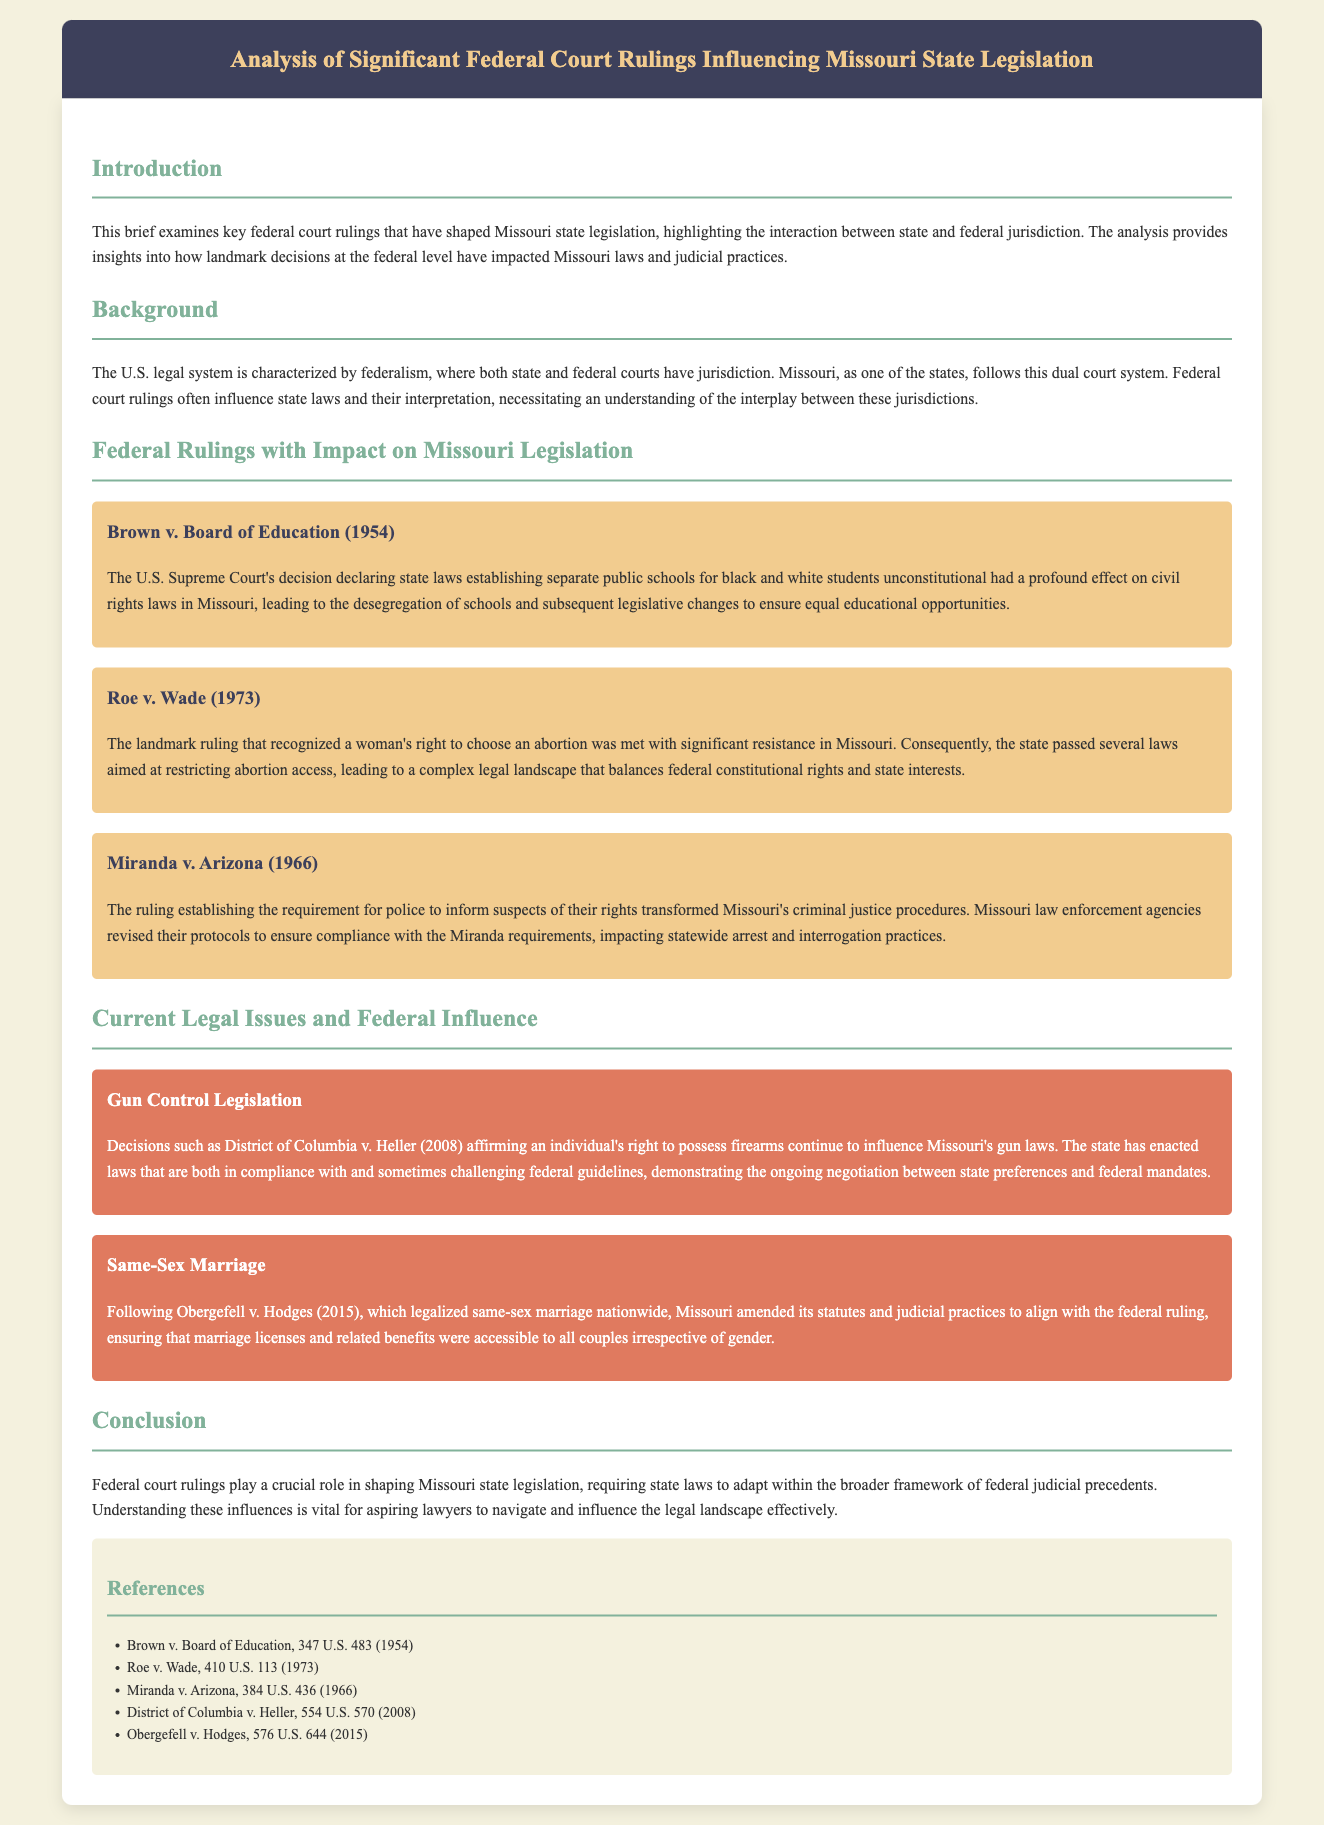What is the title of the brief? The title is prominently displayed in the header of the document, summarizing its focus on federal court rulings and Missouri legislation.
Answer: Analysis of Significant Federal Court Rulings Influencing Missouri State Legislation What year was Brown v. Board of Education decided? This is a landmark case typically recognized in educational contexts, and its citation in the document includes the year of the ruling.
Answer: 1954 Which ruling established the requirement for police to inform suspects of their rights? The document clearly states this ruling as it outlines the changes in Missouri's criminal justice procedures as a result.
Answer: Miranda v. Arizona What major issue does the current legal issue section address following Obergefell v. Hodges? The context of changing statutes and judicial practices in Missouri is outlined in relation to this federal ruling.
Answer: Same-Sex Marriage How many key federal court rulings are specifically mentioned in the brief? The document lists several significant cases that have influenced state legislation, allowing us to count them.
Answer: Five What is the main focus of the introduction section? The introduction outlines the purpose of the brief, which is to analyze the impact of federal rulings on state laws.
Answer: Key federal court rulings that have shaped Missouri state legislation What significant federal ruling affirmed an individual's right to possess firearms? The brief discusses this decision and its ongoing influence on Missouri legislation.
Answer: District of Columbia v. Heller What change was prompted by Roe v. Wade in Missouri? This ruling led to changes in state legislation regarding a woman's right to choose, making it a focal point of tension in Missouri.
Answer: Restricting abortion access What are readers encouraged to understand about federal court rulings? The conclusion emphasizes the broader implications of these rulings on state legislation and legal practices.
Answer: Require state laws to adapt within the broader framework of federal judicial precedents 